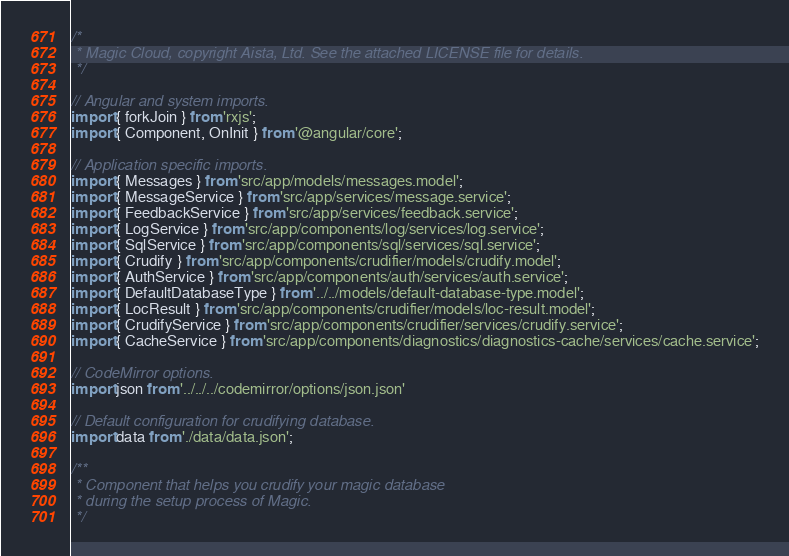<code> <loc_0><loc_0><loc_500><loc_500><_TypeScript_>
/*
 * Magic Cloud, copyright Aista, Ltd. See the attached LICENSE file for details.
 */

// Angular and system imports.
import { forkJoin } from 'rxjs';
import { Component, OnInit } from '@angular/core';

// Application specific imports.
import { Messages } from 'src/app/models/messages.model';
import { MessageService } from 'src/app/services/message.service';
import { FeedbackService } from 'src/app/services/feedback.service';
import { LogService } from 'src/app/components/log/services/log.service';
import { SqlService } from 'src/app/components/sql/services/sql.service';
import { Crudify } from 'src/app/components/crudifier/models/crudify.model';
import { AuthService } from 'src/app/components/auth/services/auth.service';
import { DefaultDatabaseType } from '../../models/default-database-type.model';
import { LocResult } from 'src/app/components/crudifier/models/loc-result.model';
import { CrudifyService } from 'src/app/components/crudifier/services/crudify.service';
import { CacheService } from 'src/app/components/diagnostics/diagnostics-cache/services/cache.service';

// CodeMirror options.
import json from '../../../codemirror/options/json.json'

// Default configuration for crudifying database.
import data from './data/data.json';

/**
 * Component that helps you crudify your magic database
 * during the setup process of Magic.
 */</code> 